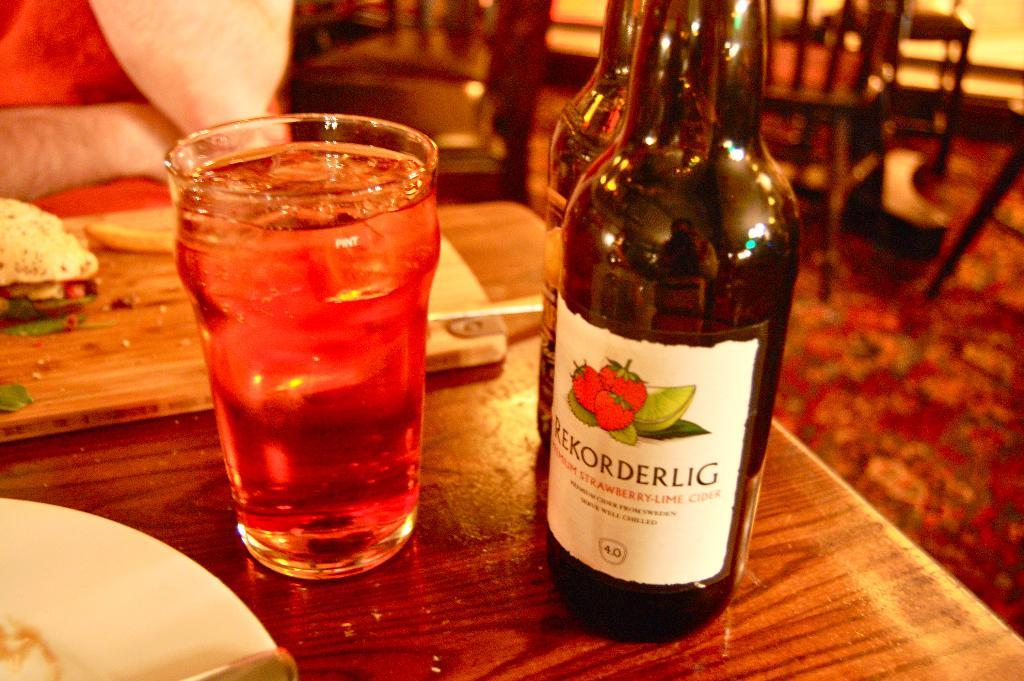<image>
Give a short and clear explanation of the subsequent image. A bottle of Rekorderlig has strawberries and kiwi on the label. 